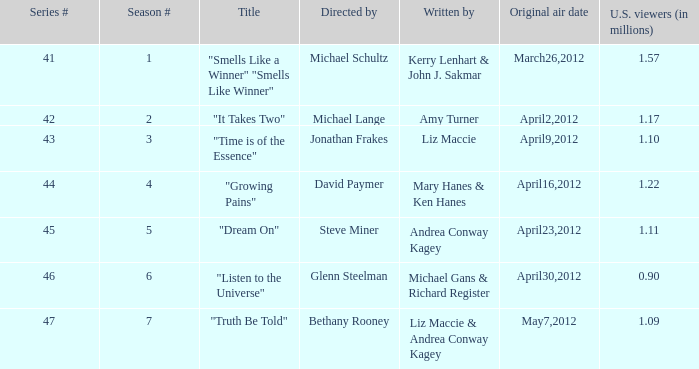When was the first broadcast of the episode titled "Truth Be Told"? May7,2012. 